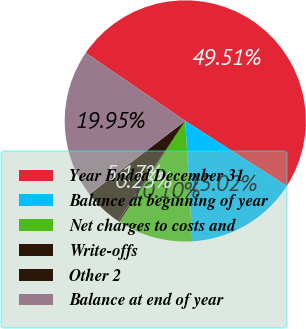Convert chart. <chart><loc_0><loc_0><loc_500><loc_500><pie_chart><fcel>Year Ended December 31<fcel>Balance at beginning of year<fcel>Net charges to costs and<fcel>Write-offs<fcel>Other 2<fcel>Balance at end of year<nl><fcel>49.51%<fcel>15.02%<fcel>10.1%<fcel>0.25%<fcel>5.17%<fcel>19.95%<nl></chart> 